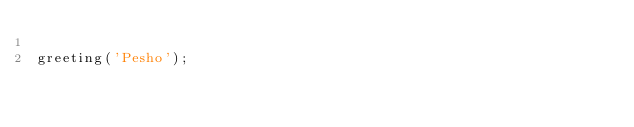Convert code to text. <code><loc_0><loc_0><loc_500><loc_500><_JavaScript_>
greeting('Pesho');</code> 